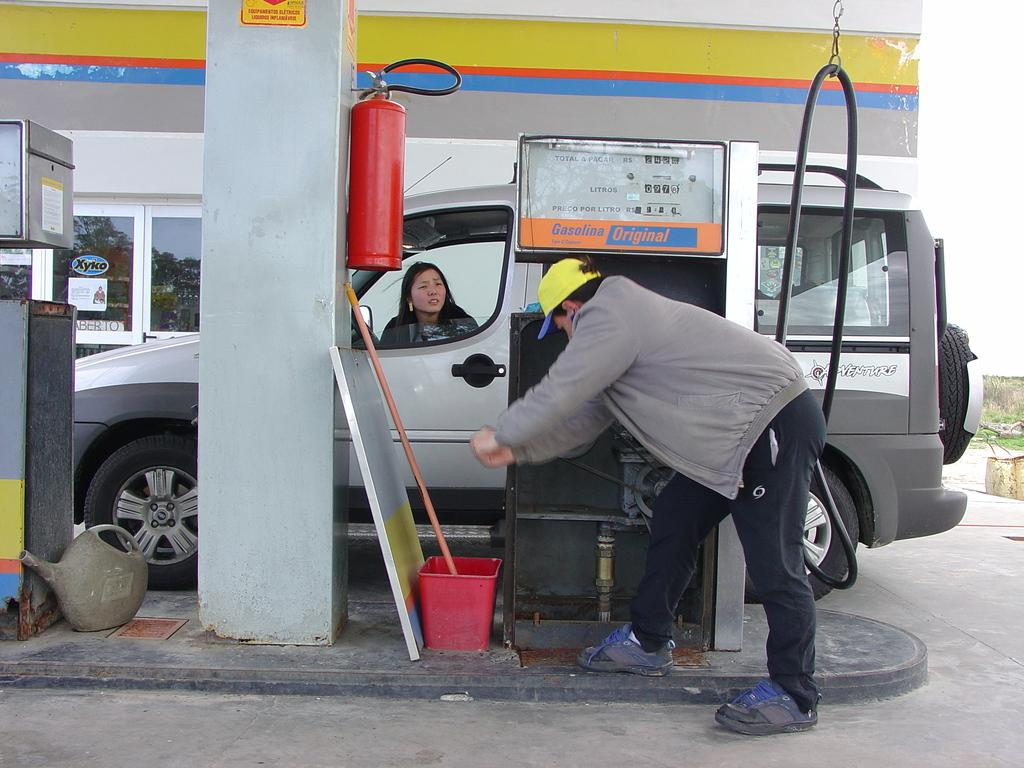How many people are present in the image? There is a man and a woman in the image. What is the setting of the image? The image shows a man and a woman at a petrol bunk where there is a car. What type of vehicle is present in the image? There is a car in the image. What type of whip is the man using to cook the meat in the image? There is no whip or meat present in the image; it features a man and a woman at a petrol bunk. 